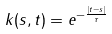Convert formula to latex. <formula><loc_0><loc_0><loc_500><loc_500>k ( s , t ) = e ^ { - \frac { | t - s | } { \tau } }</formula> 